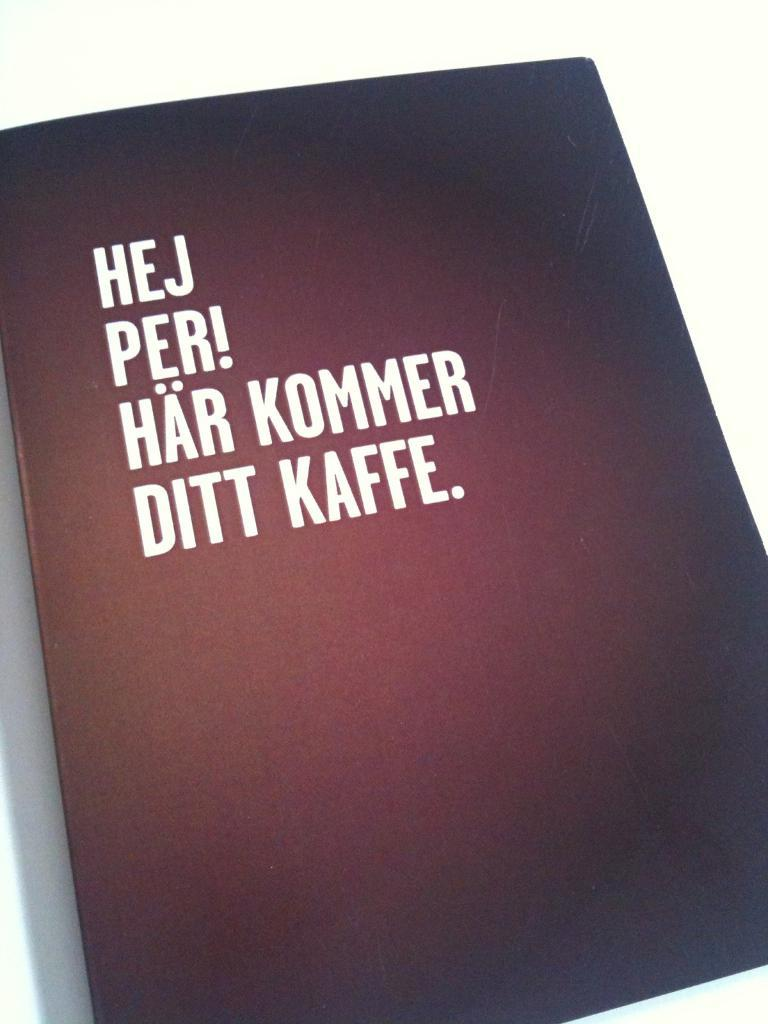<image>
Offer a succinct explanation of the picture presented. A dark book cover with white letters that read "Hej Per!. 